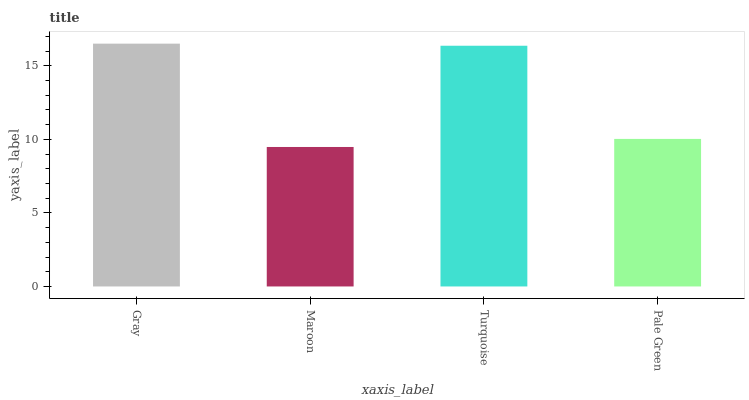Is Maroon the minimum?
Answer yes or no. Yes. Is Gray the maximum?
Answer yes or no. Yes. Is Turquoise the minimum?
Answer yes or no. No. Is Turquoise the maximum?
Answer yes or no. No. Is Turquoise greater than Maroon?
Answer yes or no. Yes. Is Maroon less than Turquoise?
Answer yes or no. Yes. Is Maroon greater than Turquoise?
Answer yes or no. No. Is Turquoise less than Maroon?
Answer yes or no. No. Is Turquoise the high median?
Answer yes or no. Yes. Is Pale Green the low median?
Answer yes or no. Yes. Is Maroon the high median?
Answer yes or no. No. Is Turquoise the low median?
Answer yes or no. No. 